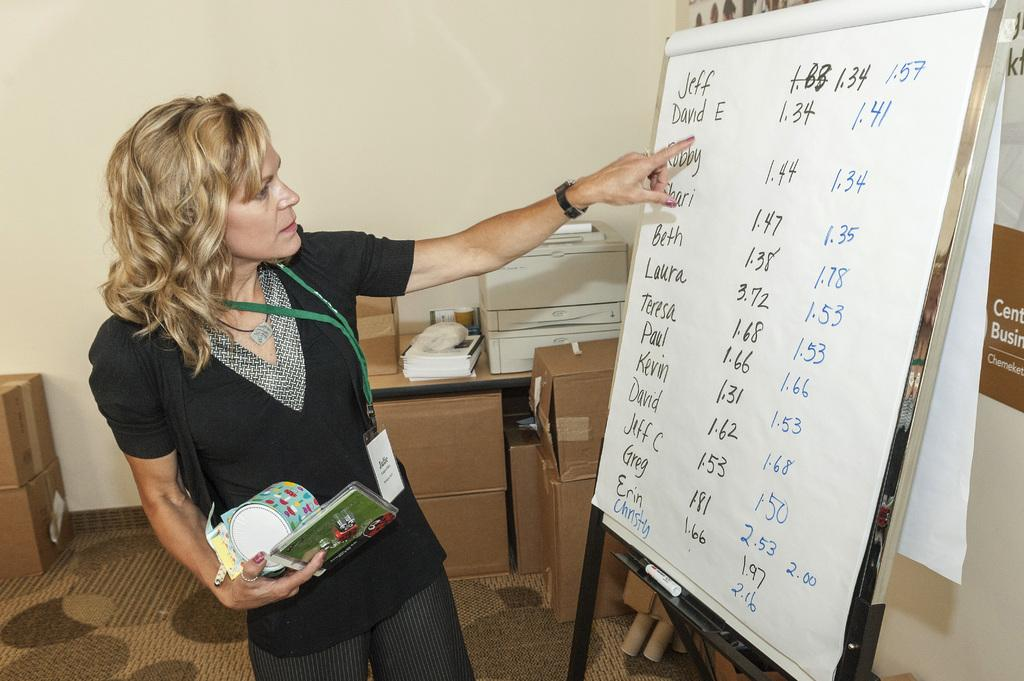<image>
Summarize the visual content of the image. A woman whose name starts with J points at a large piece of paper. 